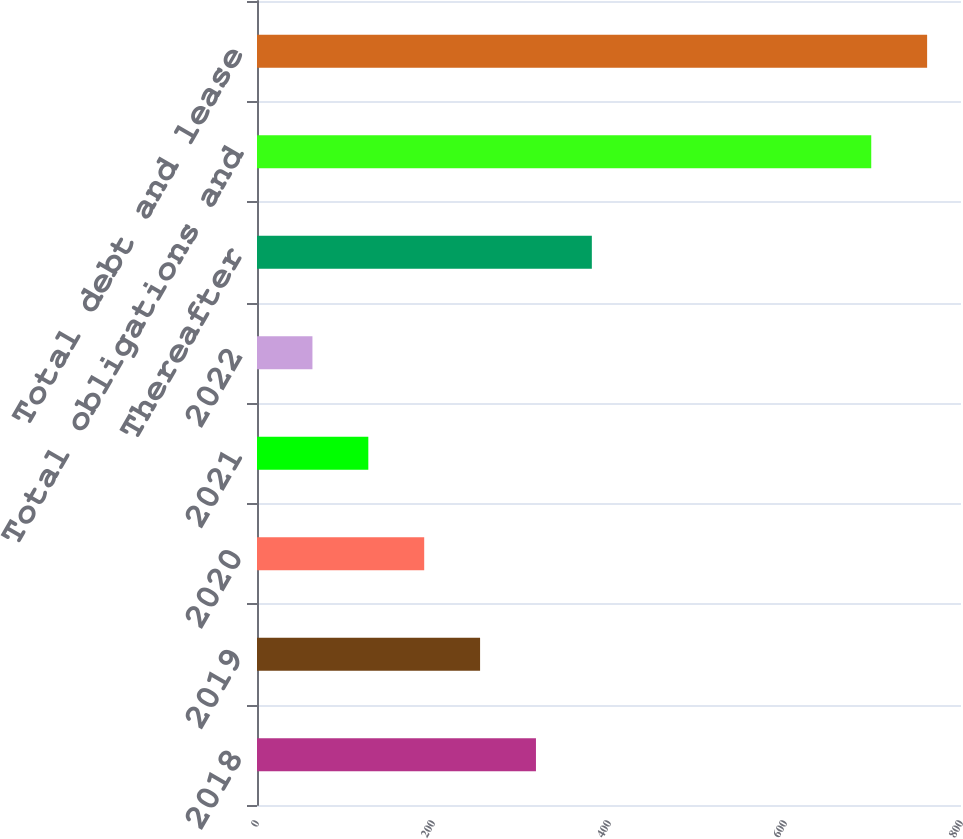<chart> <loc_0><loc_0><loc_500><loc_500><bar_chart><fcel>2018<fcel>2019<fcel>2020<fcel>2021<fcel>2022<fcel>Thereafter<fcel>Total obligations and<fcel>Total debt and lease<nl><fcel>317<fcel>253.5<fcel>190<fcel>126.5<fcel>63<fcel>380.5<fcel>698<fcel>761.5<nl></chart> 